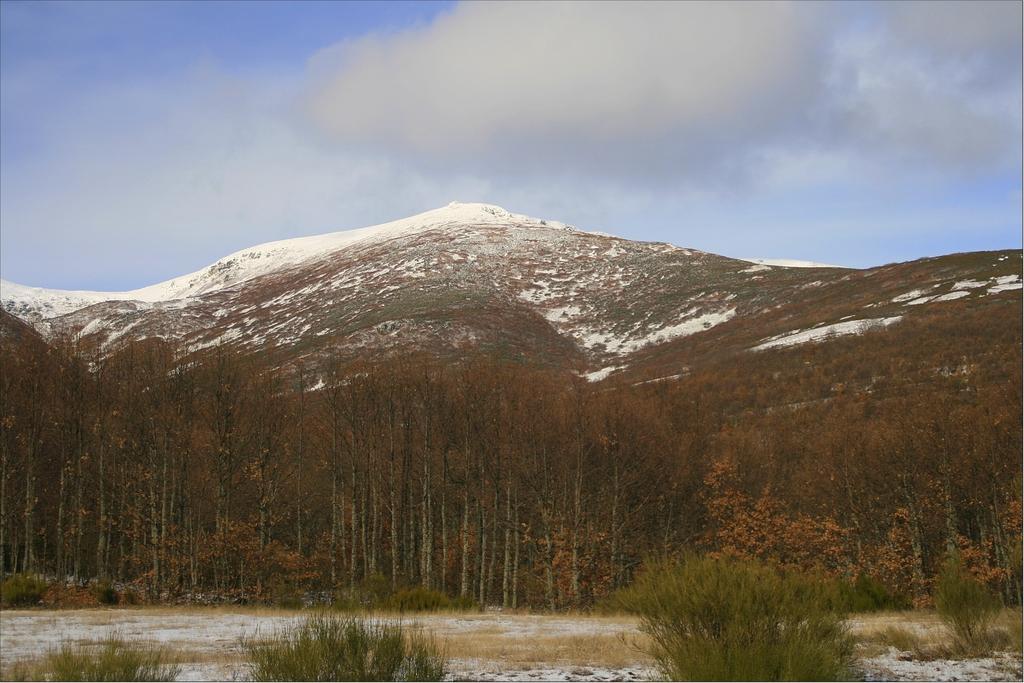Please provide a concise description of this image. In this picture we can see plants, trees, mountains, snow and in the background we can see the sky with clouds. 